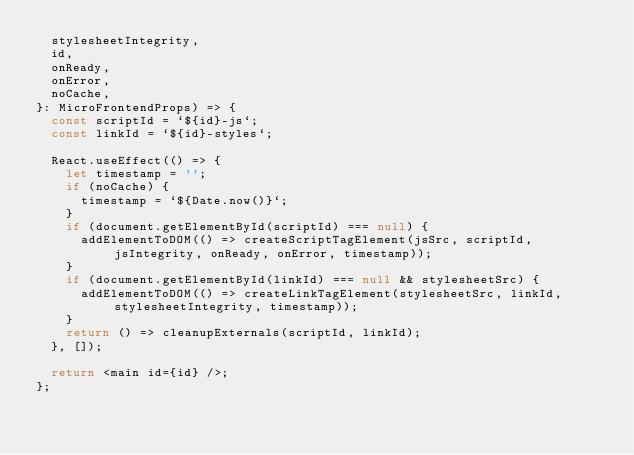Convert code to text. <code><loc_0><loc_0><loc_500><loc_500><_TypeScript_>  stylesheetIntegrity,
  id,
  onReady,
  onError,
  noCache,
}: MicroFrontendProps) => {
  const scriptId = `${id}-js`;
  const linkId = `${id}-styles`;

  React.useEffect(() => {
    let timestamp = '';
    if (noCache) {
      timestamp = `${Date.now()}`;
    }
    if (document.getElementById(scriptId) === null) {
      addElementToDOM(() => createScriptTagElement(jsSrc, scriptId, jsIntegrity, onReady, onError, timestamp));
    }
    if (document.getElementById(linkId) === null && stylesheetSrc) {
      addElementToDOM(() => createLinkTagElement(stylesheetSrc, linkId, stylesheetIntegrity, timestamp));
    }
    return () => cleanupExternals(scriptId, linkId);
  }, []);

  return <main id={id} />;
};
</code> 